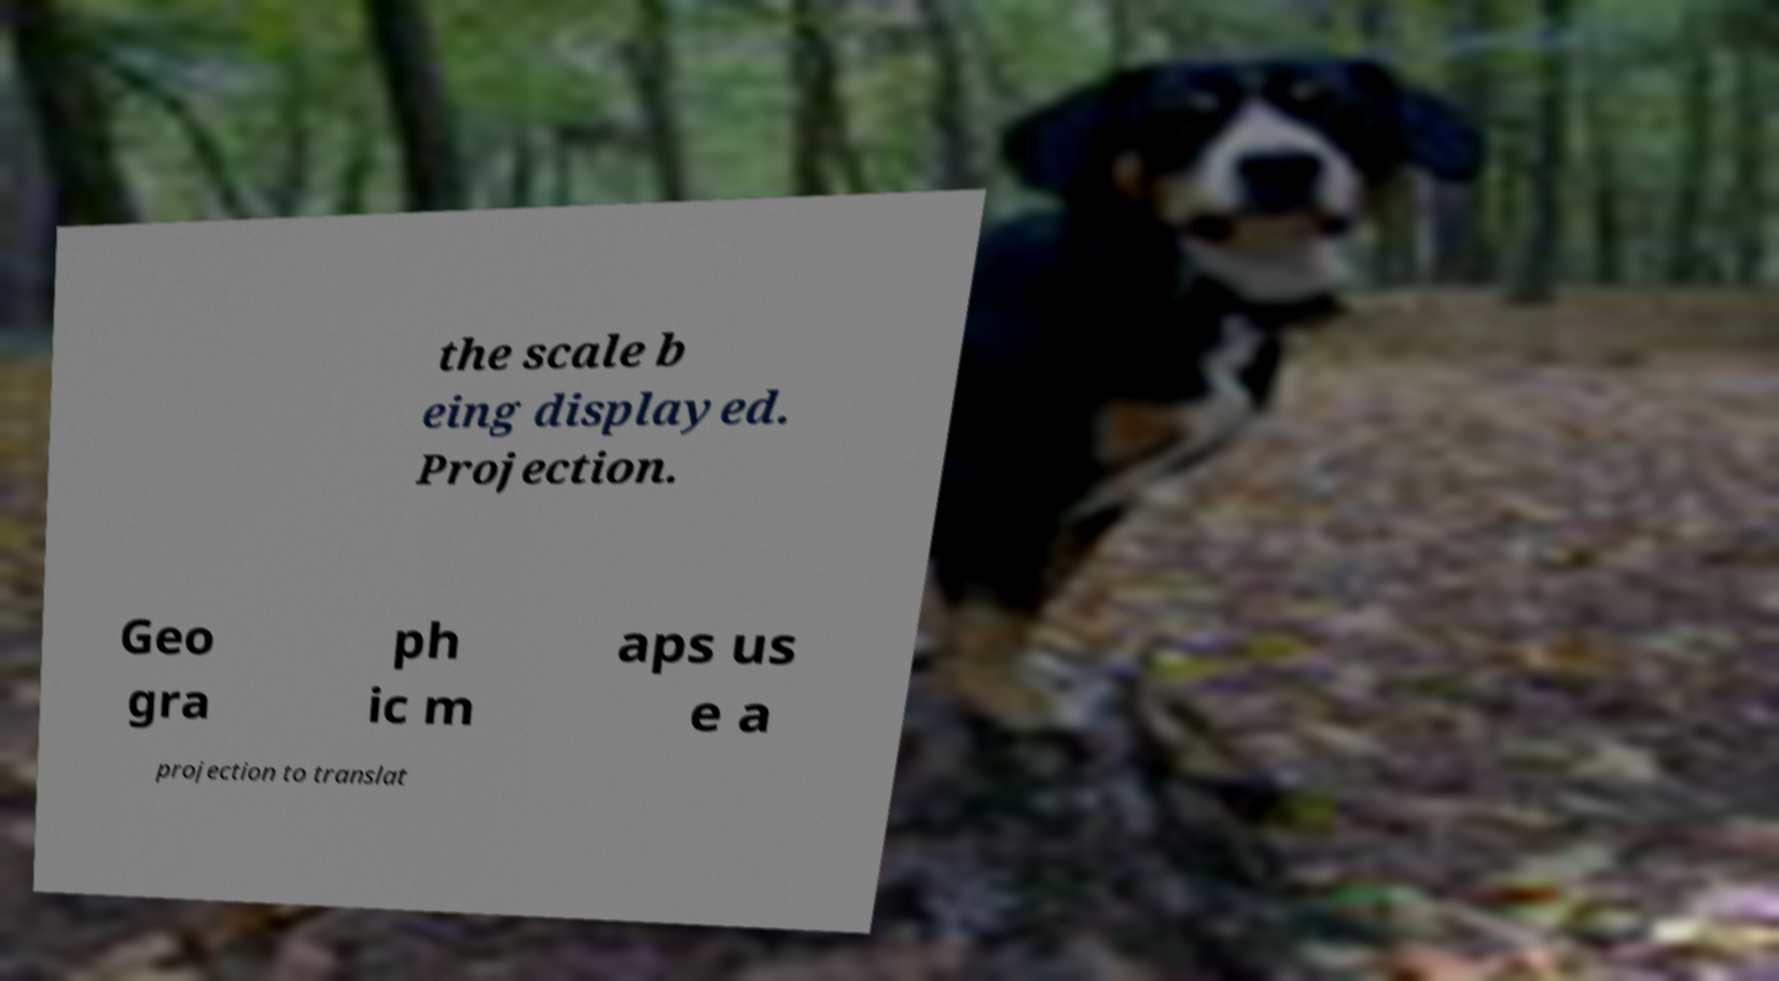Can you accurately transcribe the text from the provided image for me? the scale b eing displayed. Projection. Geo gra ph ic m aps us e a projection to translat 